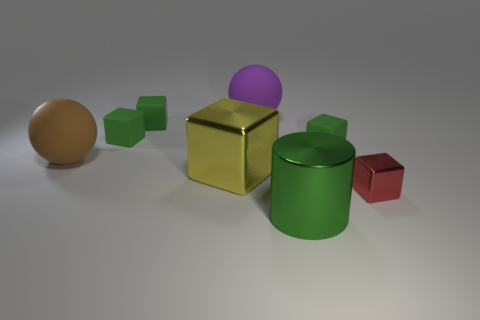The big green object that is made of the same material as the yellow cube is what shape?
Provide a succinct answer. Cylinder. Is there anything else that has the same color as the large shiny cylinder?
Ensure brevity in your answer.  Yes. What number of green blocks are there?
Provide a succinct answer. 3. What material is the ball that is in front of the green rubber cube that is on the right side of the big yellow object made of?
Offer a terse response. Rubber. What color is the large matte ball that is in front of the green rubber thing that is to the right of the big metallic thing that is on the left side of the large metallic cylinder?
Offer a very short reply. Brown. Is the color of the large metal cylinder the same as the small shiny object?
Provide a succinct answer. No. How many purple objects have the same size as the red shiny thing?
Ensure brevity in your answer.  0. Are there more purple balls that are on the left side of the small metal thing than purple things behind the yellow object?
Ensure brevity in your answer.  No. The large thing in front of the tiny shiny thing on the right side of the big brown thing is what color?
Provide a short and direct response. Green. Do the brown thing and the big block have the same material?
Offer a very short reply. No. 